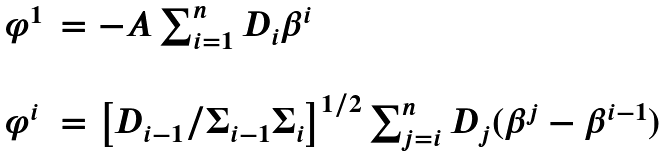<formula> <loc_0><loc_0><loc_500><loc_500>\begin{array} { l l } \varphi ^ { 1 } & = - A \sum _ { i = 1 } ^ { n } D _ { i } \beta ^ { i } \\ & \\ \varphi ^ { i } & = \left [ D _ { i - 1 } / \Sigma _ { i - 1 } \Sigma _ { i } \right ] ^ { 1 / 2 } \sum _ { j = i } ^ { n } D _ { j } ( \beta ^ { j } - \beta ^ { i - 1 } ) \end{array}</formula> 